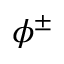<formula> <loc_0><loc_0><loc_500><loc_500>\phi ^ { \pm }</formula> 